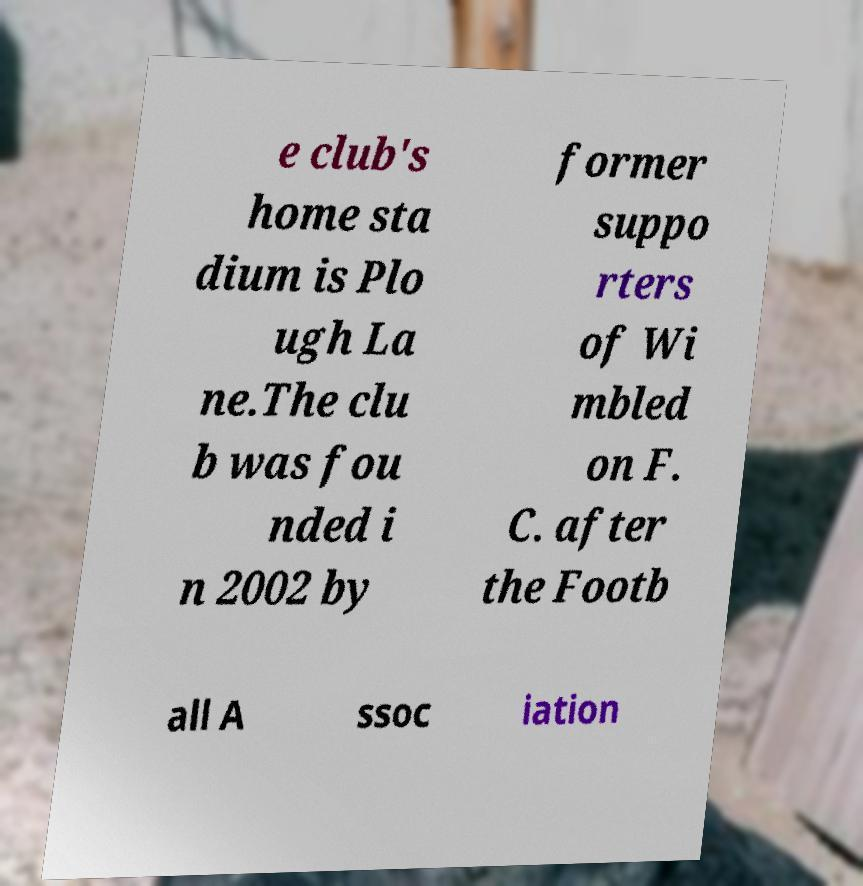Please read and relay the text visible in this image. What does it say? e club's home sta dium is Plo ugh La ne.The clu b was fou nded i n 2002 by former suppo rters of Wi mbled on F. C. after the Footb all A ssoc iation 